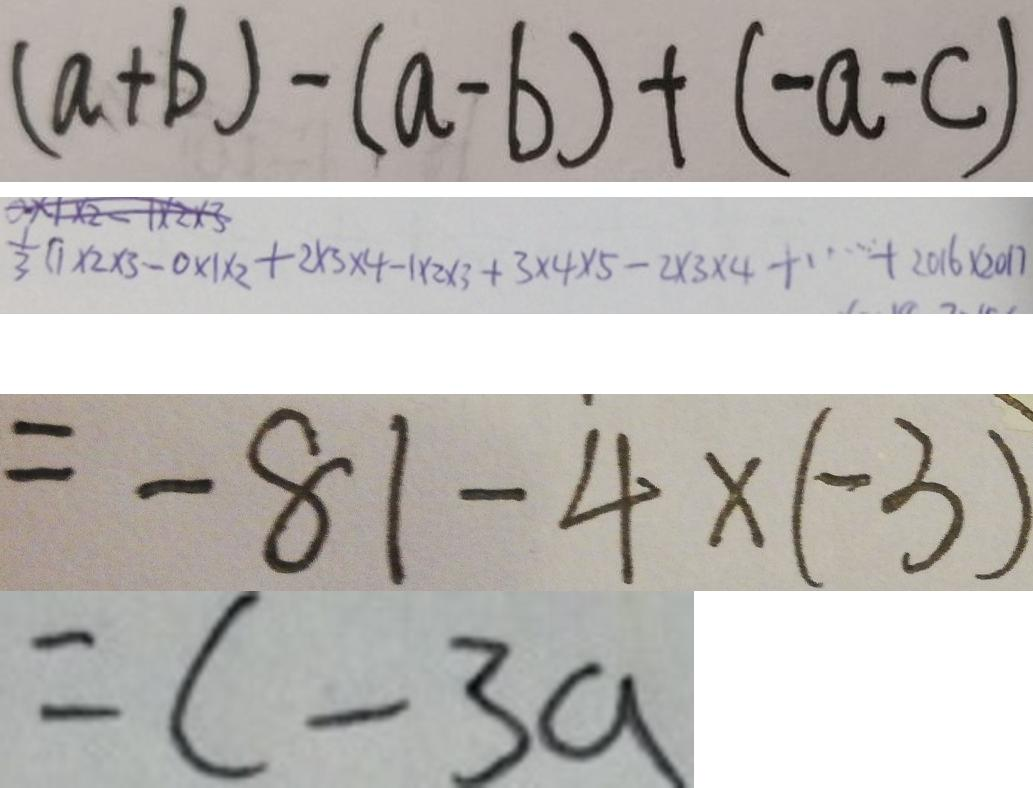Convert formula to latex. <formula><loc_0><loc_0><loc_500><loc_500>( a + b ) - ( a - b ) + ( - a - c ) 
 = \frac { 1 } { 3 } ( 1 \times 2 \times 3 - 0 \times 1 \times 2 + 2 \times 3 \times 4 - 1 \times 2 \times 3 + 3 \times 4 \times 5 - 2 \times 3 \times 4 + \cdots + 2 0 1 6 \times 2 0 1 7 
 = - 8 1 - 4 \times ( - 3 ) 
 = c - 3 a</formula> 